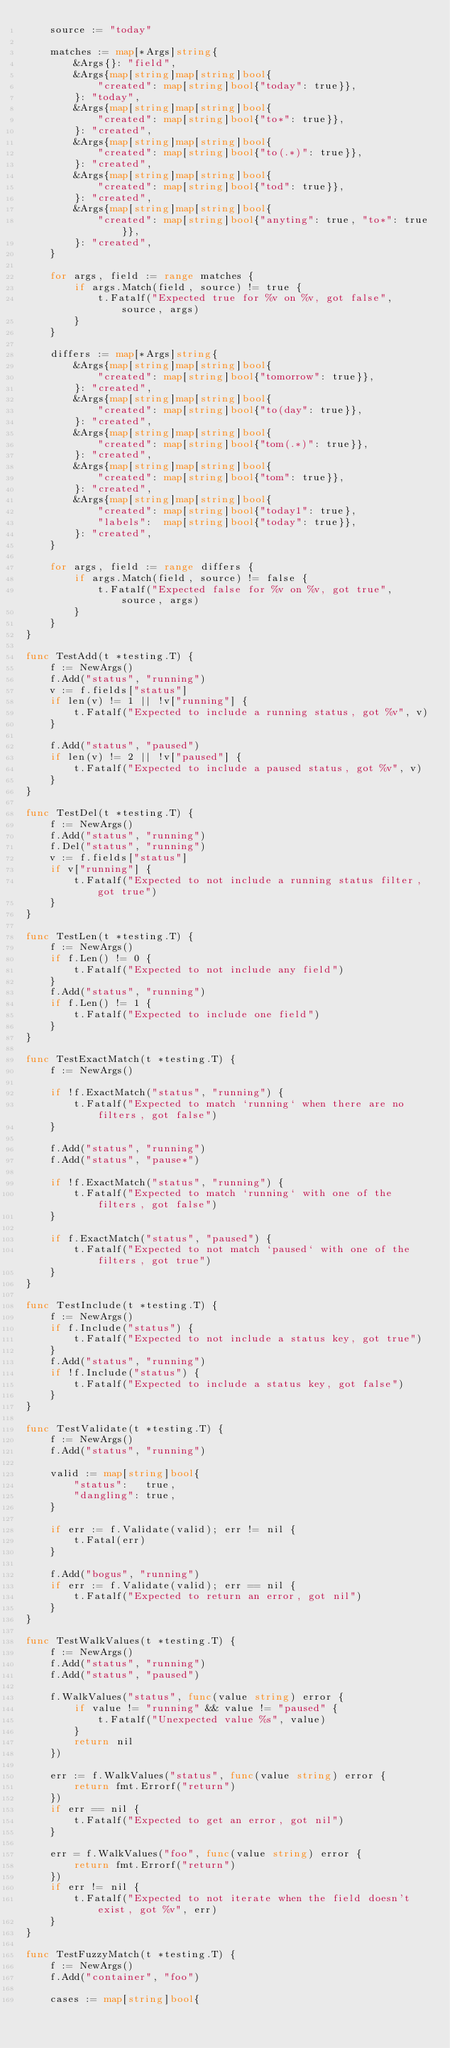<code> <loc_0><loc_0><loc_500><loc_500><_Go_>	source := "today"

	matches := map[*Args]string{
		&Args{}: "field",
		&Args{map[string]map[string]bool{
			"created": map[string]bool{"today": true}},
		}: "today",
		&Args{map[string]map[string]bool{
			"created": map[string]bool{"to*": true}},
		}: "created",
		&Args{map[string]map[string]bool{
			"created": map[string]bool{"to(.*)": true}},
		}: "created",
		&Args{map[string]map[string]bool{
			"created": map[string]bool{"tod": true}},
		}: "created",
		&Args{map[string]map[string]bool{
			"created": map[string]bool{"anyting": true, "to*": true}},
		}: "created",
	}

	for args, field := range matches {
		if args.Match(field, source) != true {
			t.Fatalf("Expected true for %v on %v, got false", source, args)
		}
	}

	differs := map[*Args]string{
		&Args{map[string]map[string]bool{
			"created": map[string]bool{"tomorrow": true}},
		}: "created",
		&Args{map[string]map[string]bool{
			"created": map[string]bool{"to(day": true}},
		}: "created",
		&Args{map[string]map[string]bool{
			"created": map[string]bool{"tom(.*)": true}},
		}: "created",
		&Args{map[string]map[string]bool{
			"created": map[string]bool{"tom": true}},
		}: "created",
		&Args{map[string]map[string]bool{
			"created": map[string]bool{"today1": true},
			"labels":  map[string]bool{"today": true}},
		}: "created",
	}

	for args, field := range differs {
		if args.Match(field, source) != false {
			t.Fatalf("Expected false for %v on %v, got true", source, args)
		}
	}
}

func TestAdd(t *testing.T) {
	f := NewArgs()
	f.Add("status", "running")
	v := f.fields["status"]
	if len(v) != 1 || !v["running"] {
		t.Fatalf("Expected to include a running status, got %v", v)
	}

	f.Add("status", "paused")
	if len(v) != 2 || !v["paused"] {
		t.Fatalf("Expected to include a paused status, got %v", v)
	}
}

func TestDel(t *testing.T) {
	f := NewArgs()
	f.Add("status", "running")
	f.Del("status", "running")
	v := f.fields["status"]
	if v["running"] {
		t.Fatalf("Expected to not include a running status filter, got true")
	}
}

func TestLen(t *testing.T) {
	f := NewArgs()
	if f.Len() != 0 {
		t.Fatalf("Expected to not include any field")
	}
	f.Add("status", "running")
	if f.Len() != 1 {
		t.Fatalf("Expected to include one field")
	}
}

func TestExactMatch(t *testing.T) {
	f := NewArgs()

	if !f.ExactMatch("status", "running") {
		t.Fatalf("Expected to match `running` when there are no filters, got false")
	}

	f.Add("status", "running")
	f.Add("status", "pause*")

	if !f.ExactMatch("status", "running") {
		t.Fatalf("Expected to match `running` with one of the filters, got false")
	}

	if f.ExactMatch("status", "paused") {
		t.Fatalf("Expected to not match `paused` with one of the filters, got true")
	}
}

func TestInclude(t *testing.T) {
	f := NewArgs()
	if f.Include("status") {
		t.Fatalf("Expected to not include a status key, got true")
	}
	f.Add("status", "running")
	if !f.Include("status") {
		t.Fatalf("Expected to include a status key, got false")
	}
}

func TestValidate(t *testing.T) {
	f := NewArgs()
	f.Add("status", "running")

	valid := map[string]bool{
		"status":   true,
		"dangling": true,
	}

	if err := f.Validate(valid); err != nil {
		t.Fatal(err)
	}

	f.Add("bogus", "running")
	if err := f.Validate(valid); err == nil {
		t.Fatalf("Expected to return an error, got nil")
	}
}

func TestWalkValues(t *testing.T) {
	f := NewArgs()
	f.Add("status", "running")
	f.Add("status", "paused")

	f.WalkValues("status", func(value string) error {
		if value != "running" && value != "paused" {
			t.Fatalf("Unexpected value %s", value)
		}
		return nil
	})

	err := f.WalkValues("status", func(value string) error {
		return fmt.Errorf("return")
	})
	if err == nil {
		t.Fatalf("Expected to get an error, got nil")
	}

	err = f.WalkValues("foo", func(value string) error {
		return fmt.Errorf("return")
	})
	if err != nil {
		t.Fatalf("Expected to not iterate when the field doesn't exist, got %v", err)
	}
}

func TestFuzzyMatch(t *testing.T) {
	f := NewArgs()
	f.Add("container", "foo")

	cases := map[string]bool{</code> 